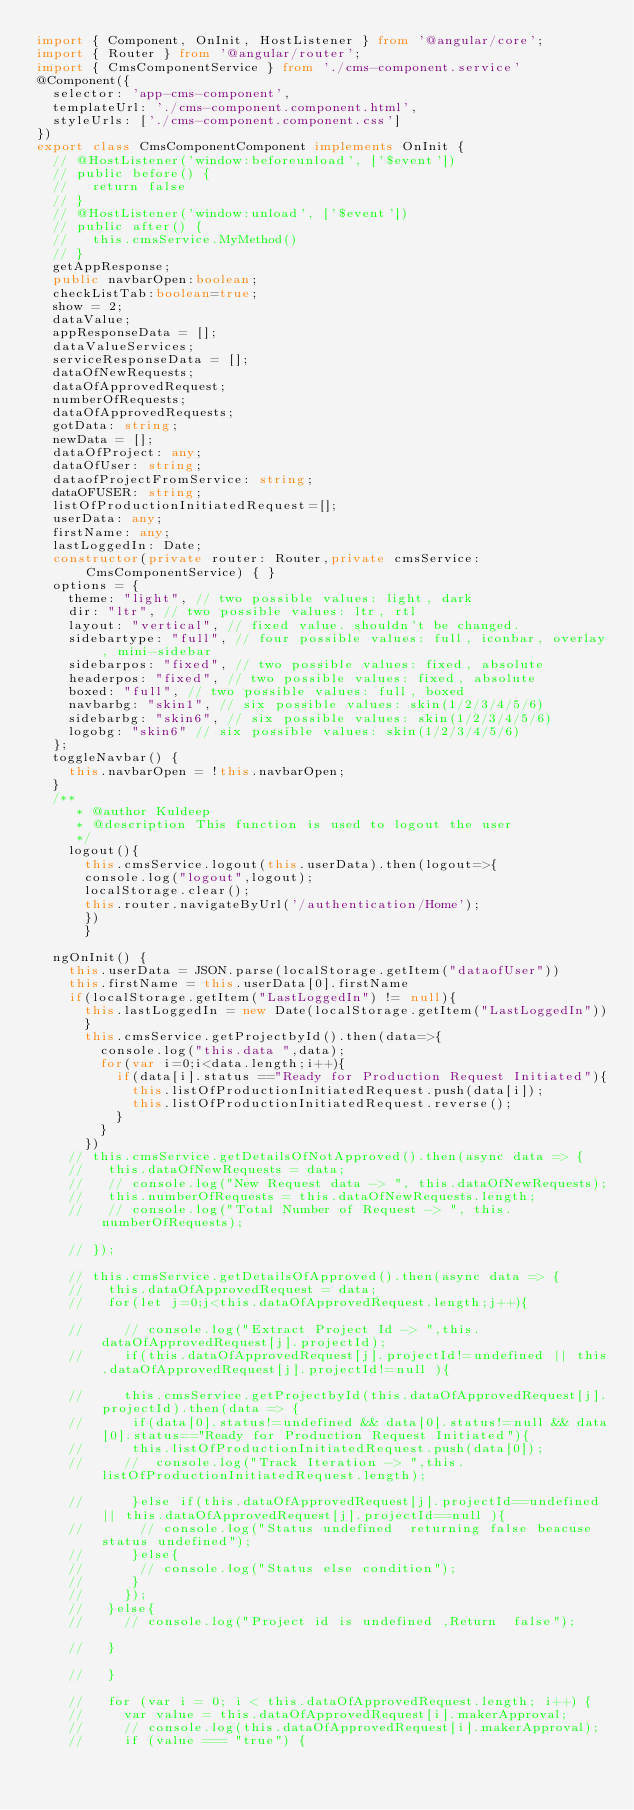Convert code to text. <code><loc_0><loc_0><loc_500><loc_500><_TypeScript_>import { Component, OnInit, HostListener } from '@angular/core';
import { Router } from '@angular/router';
import { CmsComponentService } from './cms-component.service'
@Component({
  selector: 'app-cms-component',
  templateUrl: './cms-component.component.html',
  styleUrls: ['./cms-component.component.css']
})
export class CmsComponentComponent implements OnInit {
  // @HostListener('window:beforeunload', ['$event'])
  // public before() {
  //   return false
  // }
  // @HostListener('window:unload', ['$event'])
  // public after() {
  //   this.cmsService.MyMethod()
  // }
  getAppResponse;
  public navbarOpen:boolean;
  checkListTab:boolean=true;
  show = 2;
  dataValue;
  appResponseData = [];
  dataValueServices;
  serviceResponseData = [];
  dataOfNewRequests;
  dataOfApprovedRequest;
  numberOfRequests;
  dataOfApprovedRequests;
  gotData: string;
  newData = [];
  dataOfProject: any;
  dataOfUser: string;
  dataofProjectFromService: string;
  dataOFUSER: string;
  listOfProductionInitiatedRequest=[];
  userData: any;
  firstName: any;
  lastLoggedIn: Date;
  constructor(private router: Router,private cmsService:CmsComponentService) { }
  options = {
    theme: "light", // two possible values: light, dark
    dir: "ltr", // two possible values: ltr, rtl
    layout: "vertical", // fixed value. shouldn't be changed.
    sidebartype: "full", // four possible values: full, iconbar, overlay, mini-sidebar
    sidebarpos: "fixed", // two possible values: fixed, absolute
    headerpos: "fixed", // two possible values: fixed, absolute
    boxed: "full", // two possible values: full, boxed
    navbarbg: "skin1", // six possible values: skin(1/2/3/4/5/6)
    sidebarbg: "skin6", // six possible values: skin(1/2/3/4/5/6)
    logobg: "skin6" // six possible values: skin(1/2/3/4/5/6)
  };
  toggleNavbar() {
    this.navbarOpen = !this.navbarOpen;
  }
  /**
     * @author Kuldeep 
     * @description This function is used to logout the user 
     */
    logout(){
      this.cmsService.logout(this.userData).then(logout=>{
      console.log("logout",logout);
      localStorage.clear();
      this.router.navigateByUrl('/authentication/Home');
      })
      }

  ngOnInit() {
    this.userData = JSON.parse(localStorage.getItem("dataofUser"))
    this.firstName = this.userData[0].firstName
    if(localStorage.getItem("LastLoggedIn") != null){
      this.lastLoggedIn = new Date(localStorage.getItem("LastLoggedIn"))
      }
      this.cmsService.getProjectbyId().then(data=>{
        console.log("this.data ",data);
        for(var i=0;i<data.length;i++){
          if(data[i].status =="Ready for Production Request Initiated"){
            this.listOfProductionInitiatedRequest.push(data[i]);
            this.listOfProductionInitiatedRequest.reverse();
          }
        }
      })
    // this.cmsService.getDetailsOfNotApproved().then(async data => {
    //   this.dataOfNewRequests = data;
    //   // console.log("New Request data -> ", this.dataOfNewRequests);
    //   this.numberOfRequests = this.dataOfNewRequests.length;
    //   // console.log("Total Number of Request -> ", this.numberOfRequests);
      
    // });
  
    // this.cmsService.getDetailsOfApproved().then(async data => {
    //   this.dataOfApprovedRequest = data;
    //   for(let j=0;j<this.dataOfApprovedRequest.length;j++){

    //     // console.log("Extract Project Id -> ",this.dataOfApprovedRequest[j].projectId);
    //     if(this.dataOfApprovedRequest[j].projectId!=undefined || this.dataOfApprovedRequest[j].projectId!=null ){

    //     this.cmsService.getProjectbyId(this.dataOfApprovedRequest[j].projectId).then(data => {
    //      if(data[0].status!=undefined && data[0].status!=null && data[0].status=="Ready for Production Request Initiated"){
    //      this.listOfProductionInitiatedRequest.push(data[0]);
    //     //  console.log("Track Iteration -> ",this.listOfProductionInitiatedRequest.length);
         
    //      }else if(this.dataOfApprovedRequest[j].projectId==undefined || this.dataOfApprovedRequest[j].projectId==null ){
    //       // console.log("Status undefined  returning false beacuse status undefined");  
    //      }else{
    //       // console.log("Status else condition");  
    //      }
    //     });
    //   }else{
    //     // console.log("Project id is undefined ,Return  false");
        
    //   }

    //   }
     
    //   for (var i = 0; i < this.dataOfApprovedRequest.length; i++) {
    //     var value = this.dataOfApprovedRequest[i].makerApproval;
    //     // console.log(this.dataOfApprovedRequest[i].makerApproval);
    //     if (value === "true") {</code> 